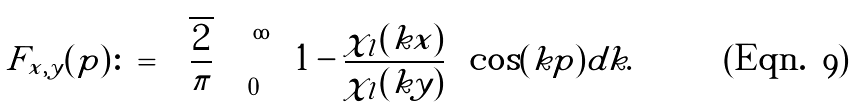Convert formula to latex. <formula><loc_0><loc_0><loc_500><loc_500>F _ { x , y } ( p ) \colon = \sqrt { \frac { 2 } { \pi } } \int _ { 0 } ^ { \infty } \left ( 1 - \frac { \chi _ { l } ( k x ) } { \chi _ { l } ( k y ) } \right ) \cos ( k p ) d k .</formula> 